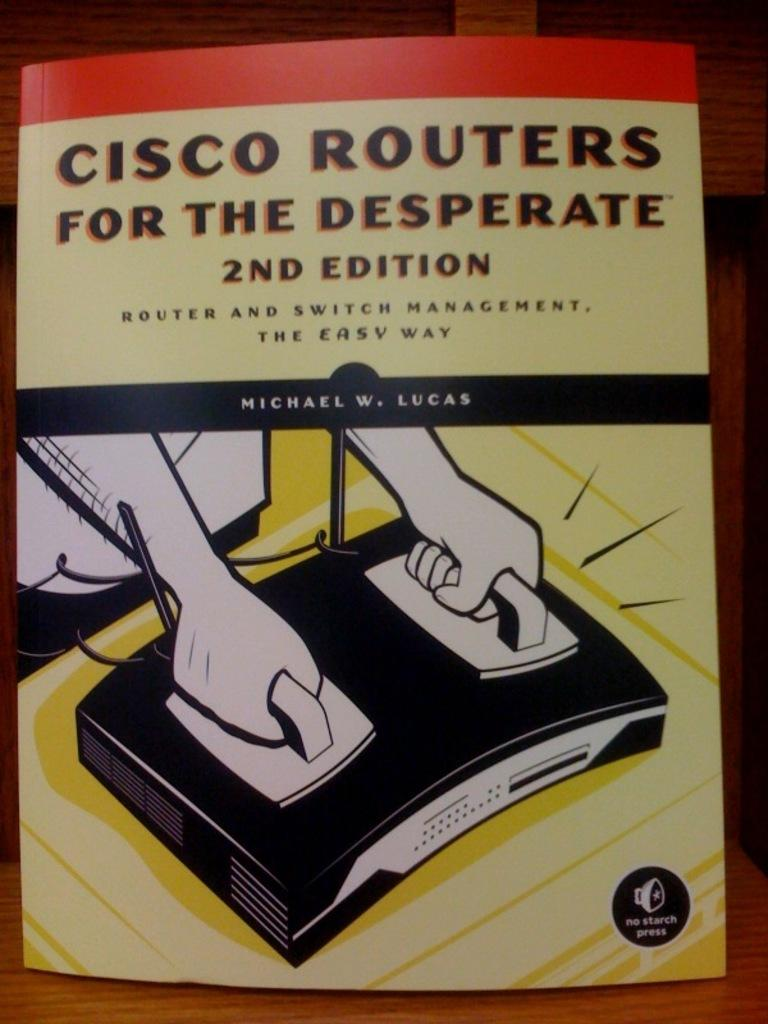<image>
Create a compact narrative representing the image presented. A 2nd edition, router and switch management has a warning, "no starch press" and an iron with a star on the bottom. 